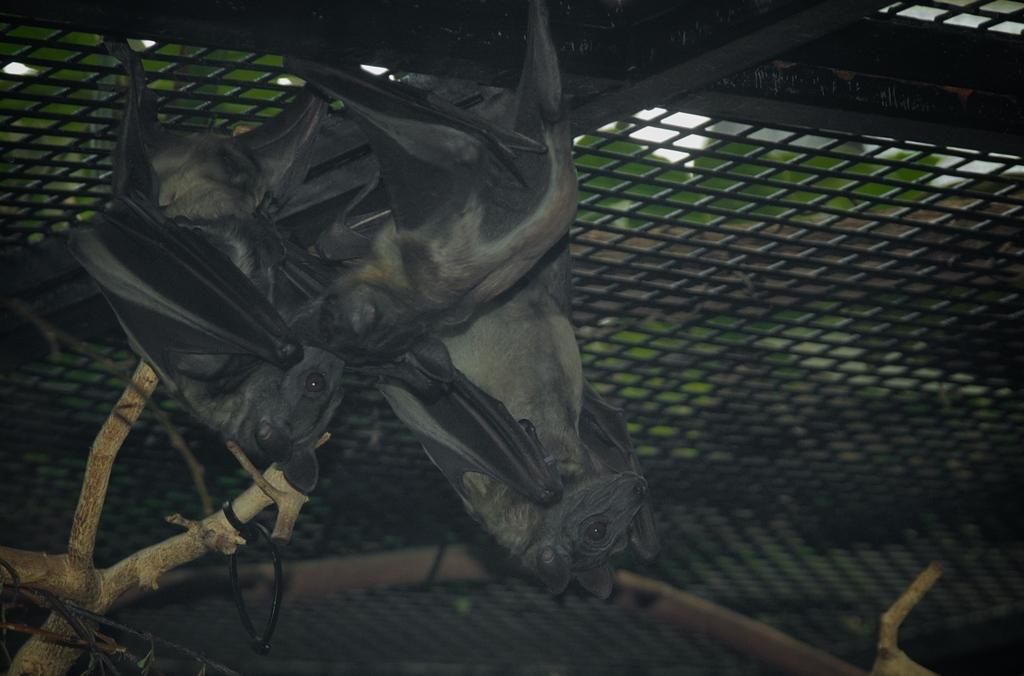What type of animals can be seen in the image? There are bats visible in the image. How are the bats positioned in the image? The bats are attached to a fence. Can you describe any other objects in the image? There is a wooden stem visible in the bottom left of the image. What is the mass of the room in the image? There is no room present in the image, so it is not possible to determine its mass. 